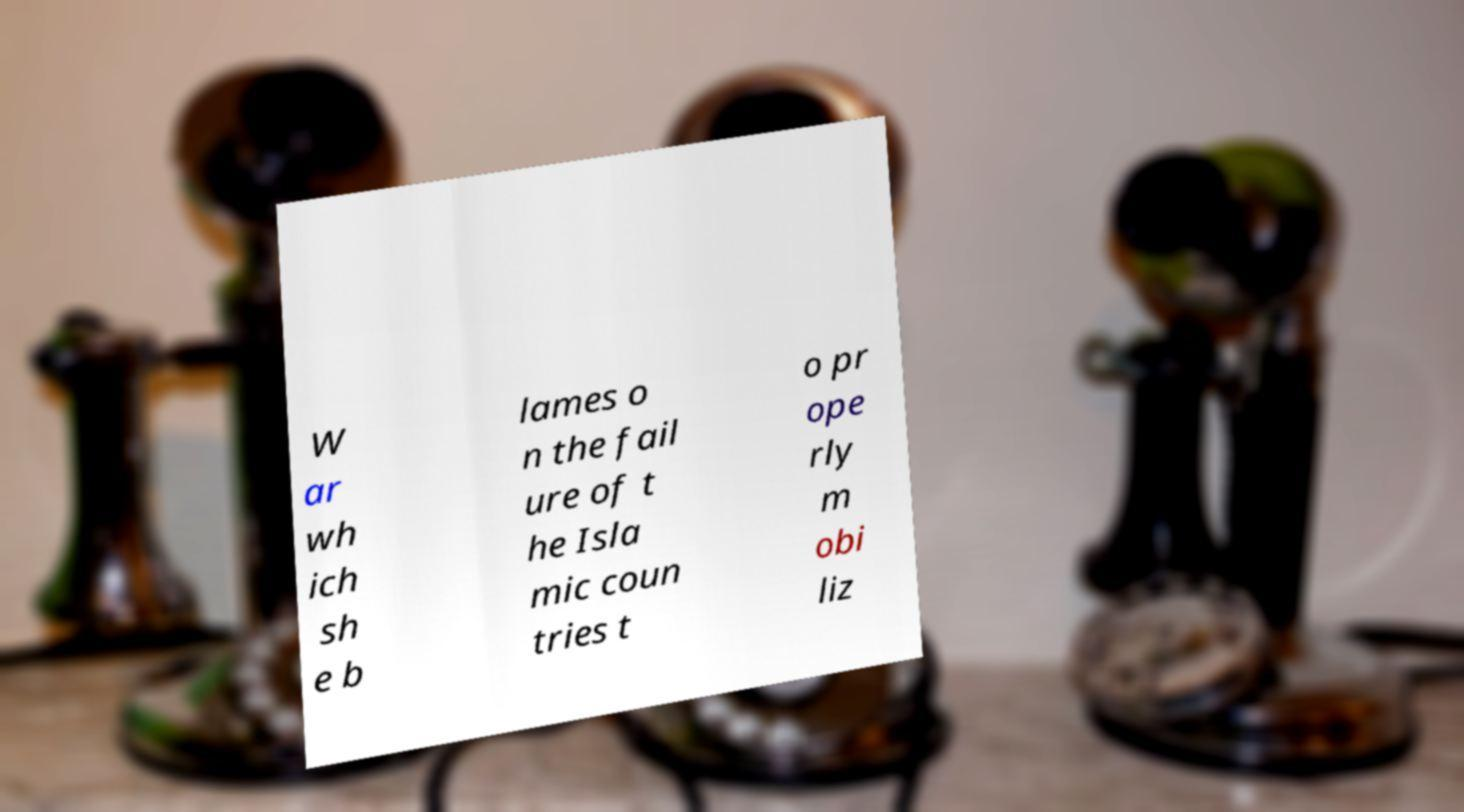What messages or text are displayed in this image? I need them in a readable, typed format. W ar wh ich sh e b lames o n the fail ure of t he Isla mic coun tries t o pr ope rly m obi liz 